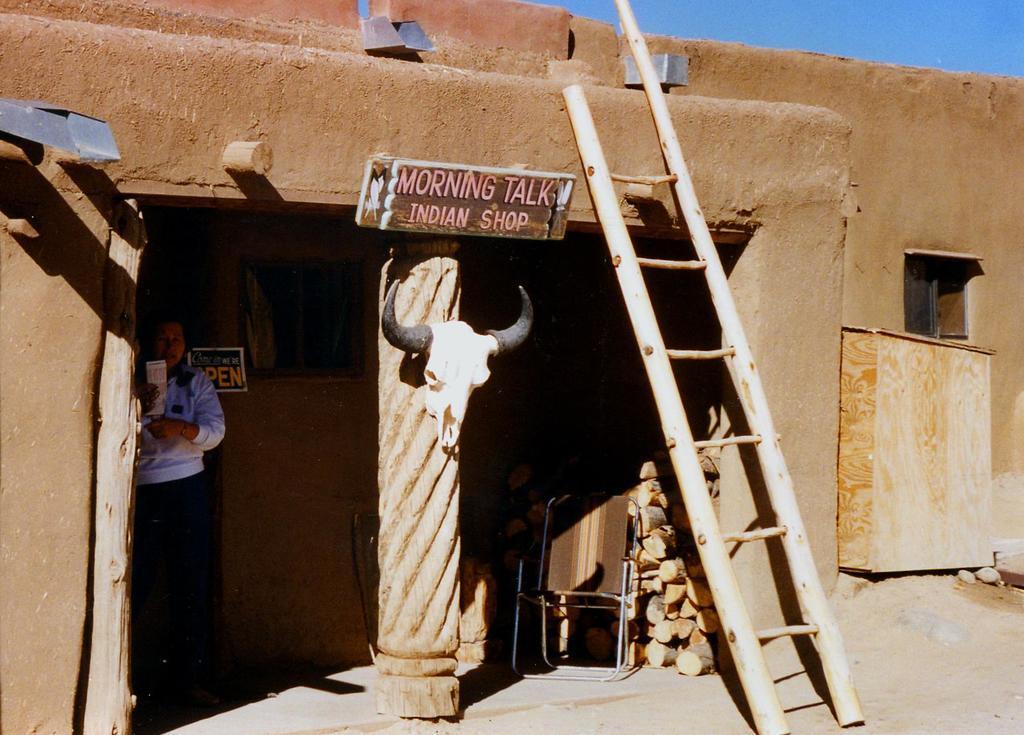Describe this image in one or two sentences. In this image I can see a person standing and the person is wearing white shirt, black pant and I can also see a ladder and a board attached to the building and the building is in brown color. Background the sky is in blue color. 